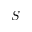<formula> <loc_0><loc_0><loc_500><loc_500>S</formula> 